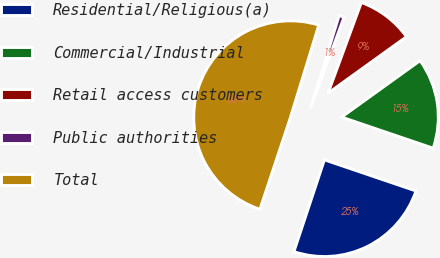Convert chart to OTSL. <chart><loc_0><loc_0><loc_500><loc_500><pie_chart><fcel>Residential/Religious(a)<fcel>Commercial/Industrial<fcel>Retail access customers<fcel>Public authorities<fcel>Total<nl><fcel>24.89%<fcel>15.14%<fcel>9.47%<fcel>0.86%<fcel>49.64%<nl></chart> 